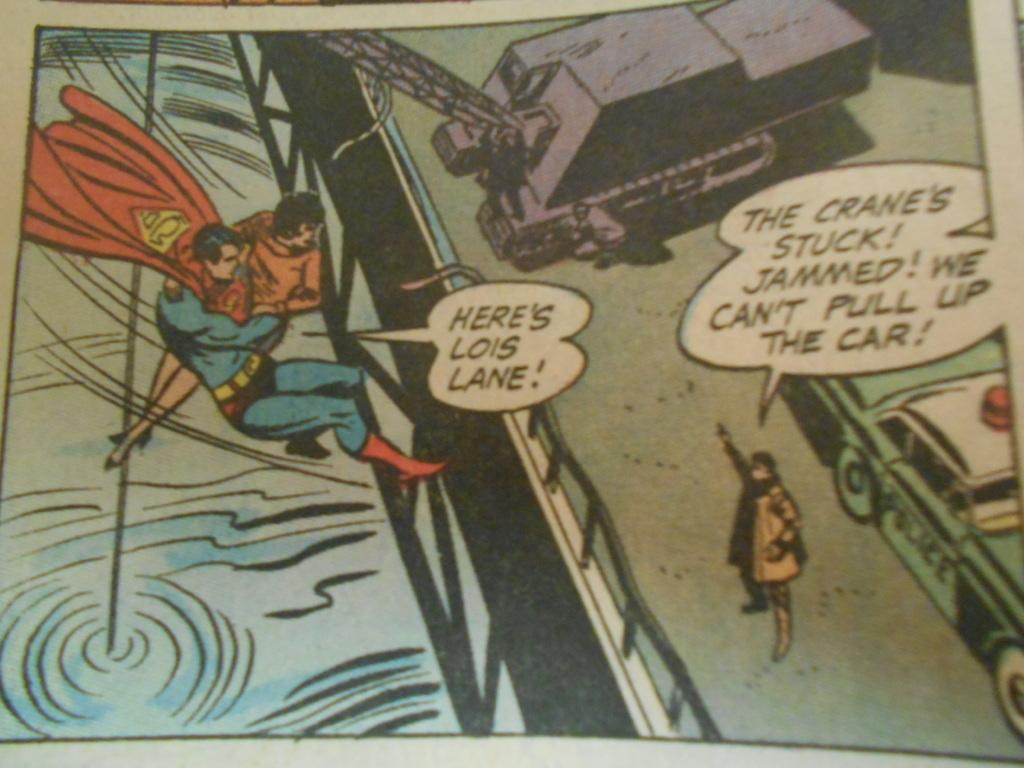<image>
Render a clear and concise summary of the photo. Superman carries Lois Lane while someone on the ground informs him of a problem. 